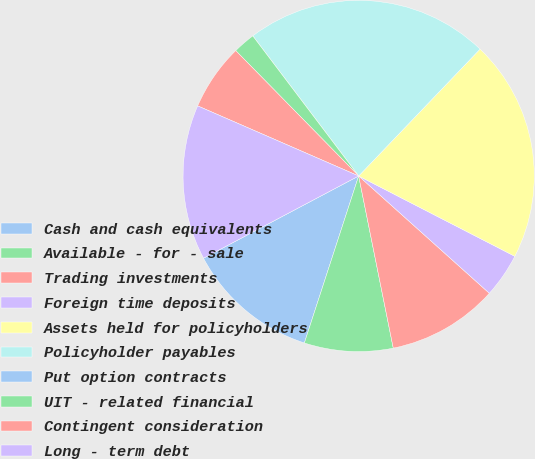Convert chart to OTSL. <chart><loc_0><loc_0><loc_500><loc_500><pie_chart><fcel>Cash and cash equivalents<fcel>Available - for - sale<fcel>Trading investments<fcel>Foreign time deposits<fcel>Assets held for policyholders<fcel>Policyholder payables<fcel>Put option contracts<fcel>UIT - related financial<fcel>Contingent consideration<fcel>Long - term debt<nl><fcel>12.24%<fcel>8.16%<fcel>10.2%<fcel>4.08%<fcel>20.41%<fcel>22.45%<fcel>0.0%<fcel>2.04%<fcel>6.12%<fcel>14.29%<nl></chart> 